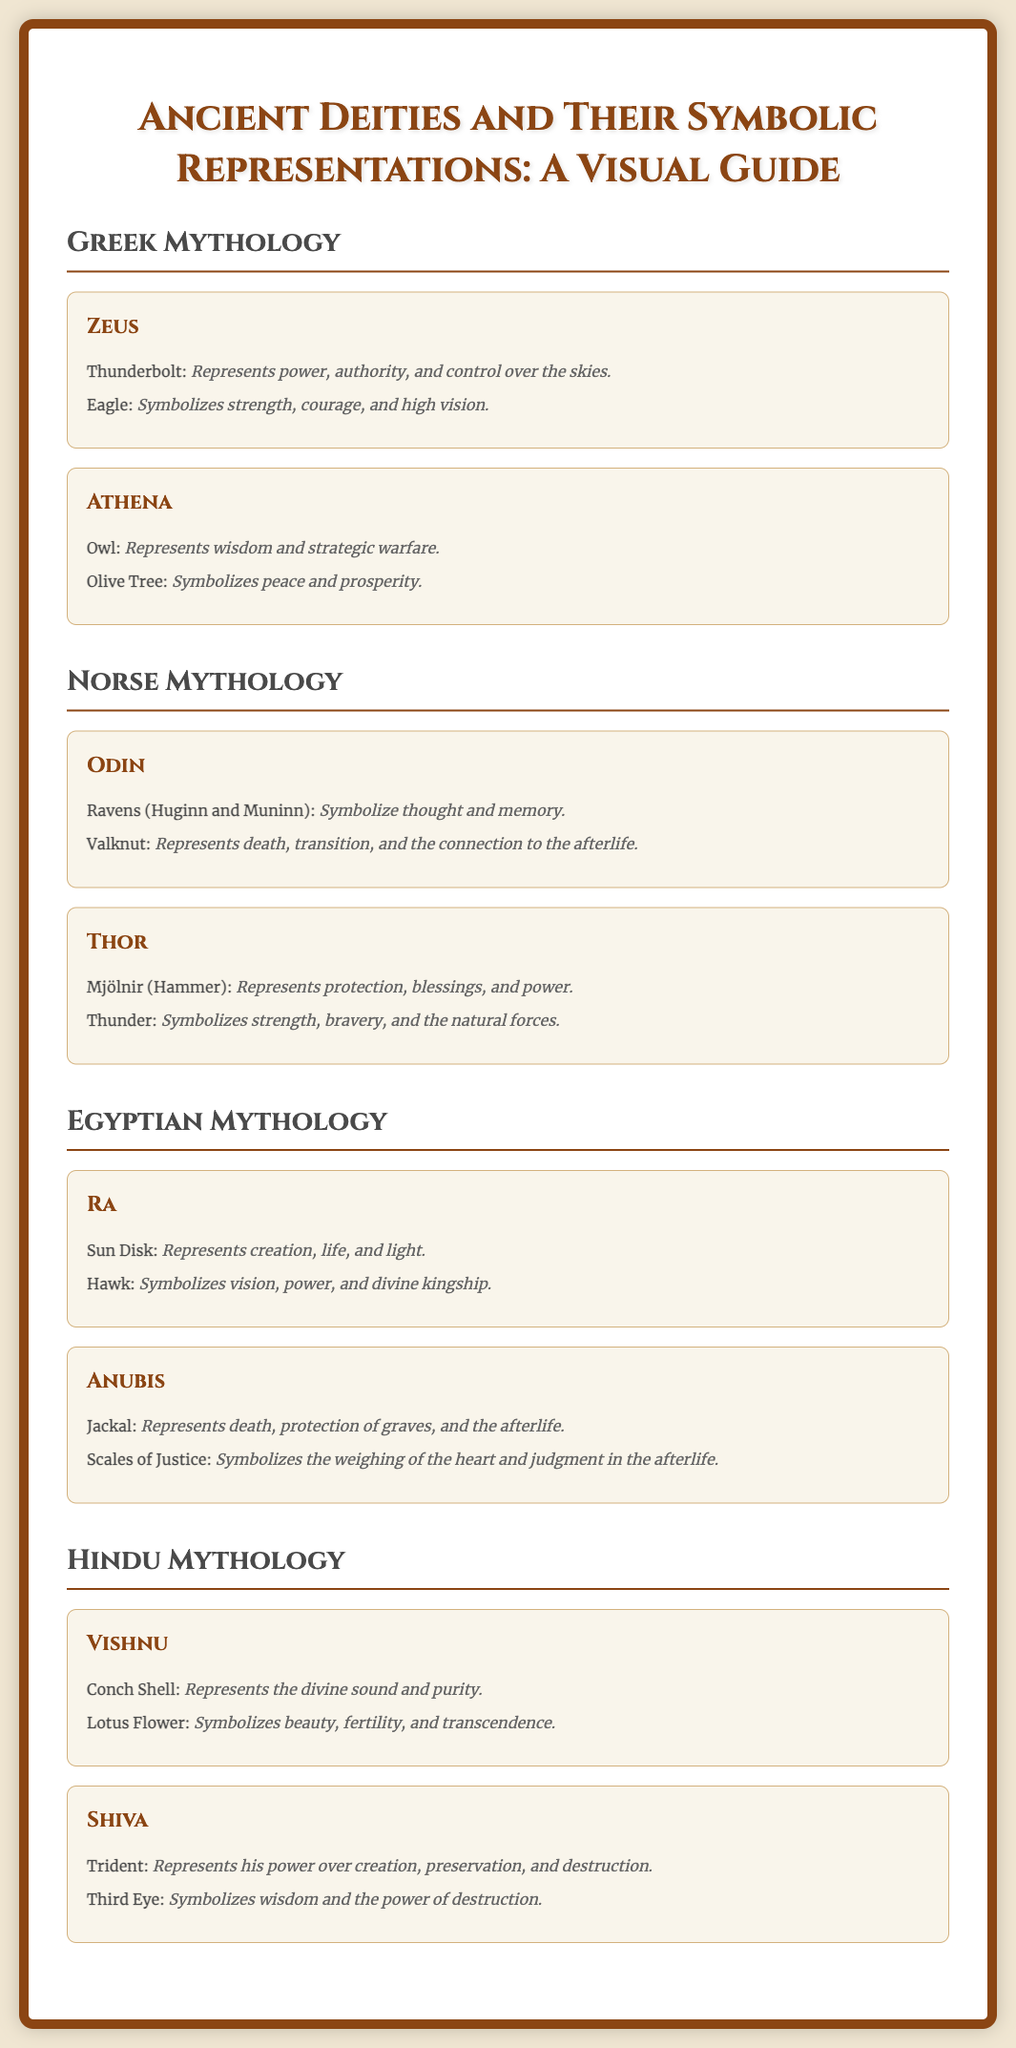What are the symbols associated with Zeus? The document lists symbols for Zeus, including the Thunderbolt and the Eagle.
Answer: Thunderbolt, Eagle Which deity represents wisdom in Greek mythology? Athena is specifically mentioned as representing wisdom.
Answer: Athena What does the Valknut symbolize in Norse mythology? The Valknut is described as representing death, transition, and the connection to the afterlife.
Answer: Death, transition, and connection to the afterlife How many symbols are listed for Anubis? The document provides two symbols associated with Anubis, a Jackal and the Scales of Justice.
Answer: Two What does the Lotus Flower symbolize in Hindu mythology? The Lotus Flower is said to symbolize beauty, fertility, and transcendence.
Answer: Beauty, fertility, and transcendence Which animal symbolizes strength and bravery in Norse mythology? Thunder is the associated representation for strength and bravery in the context of Thor.
Answer: Thunder Which Egyptian deity is associated with the Sun Disk? Ra is the deity that is associated with the Sun Disk as per the document.
Answer: Ra What is the common representation of Vishnu? The document mentions the Conch Shell and Lotus Flower as representations of Vishnu.
Answer: Conch Shell, Lotus Flower What is represented by the Third Eye in Hindu mythology? The Third Eye symbolizes wisdom and the power of destruction.
Answer: Wisdom and the power of destruction 